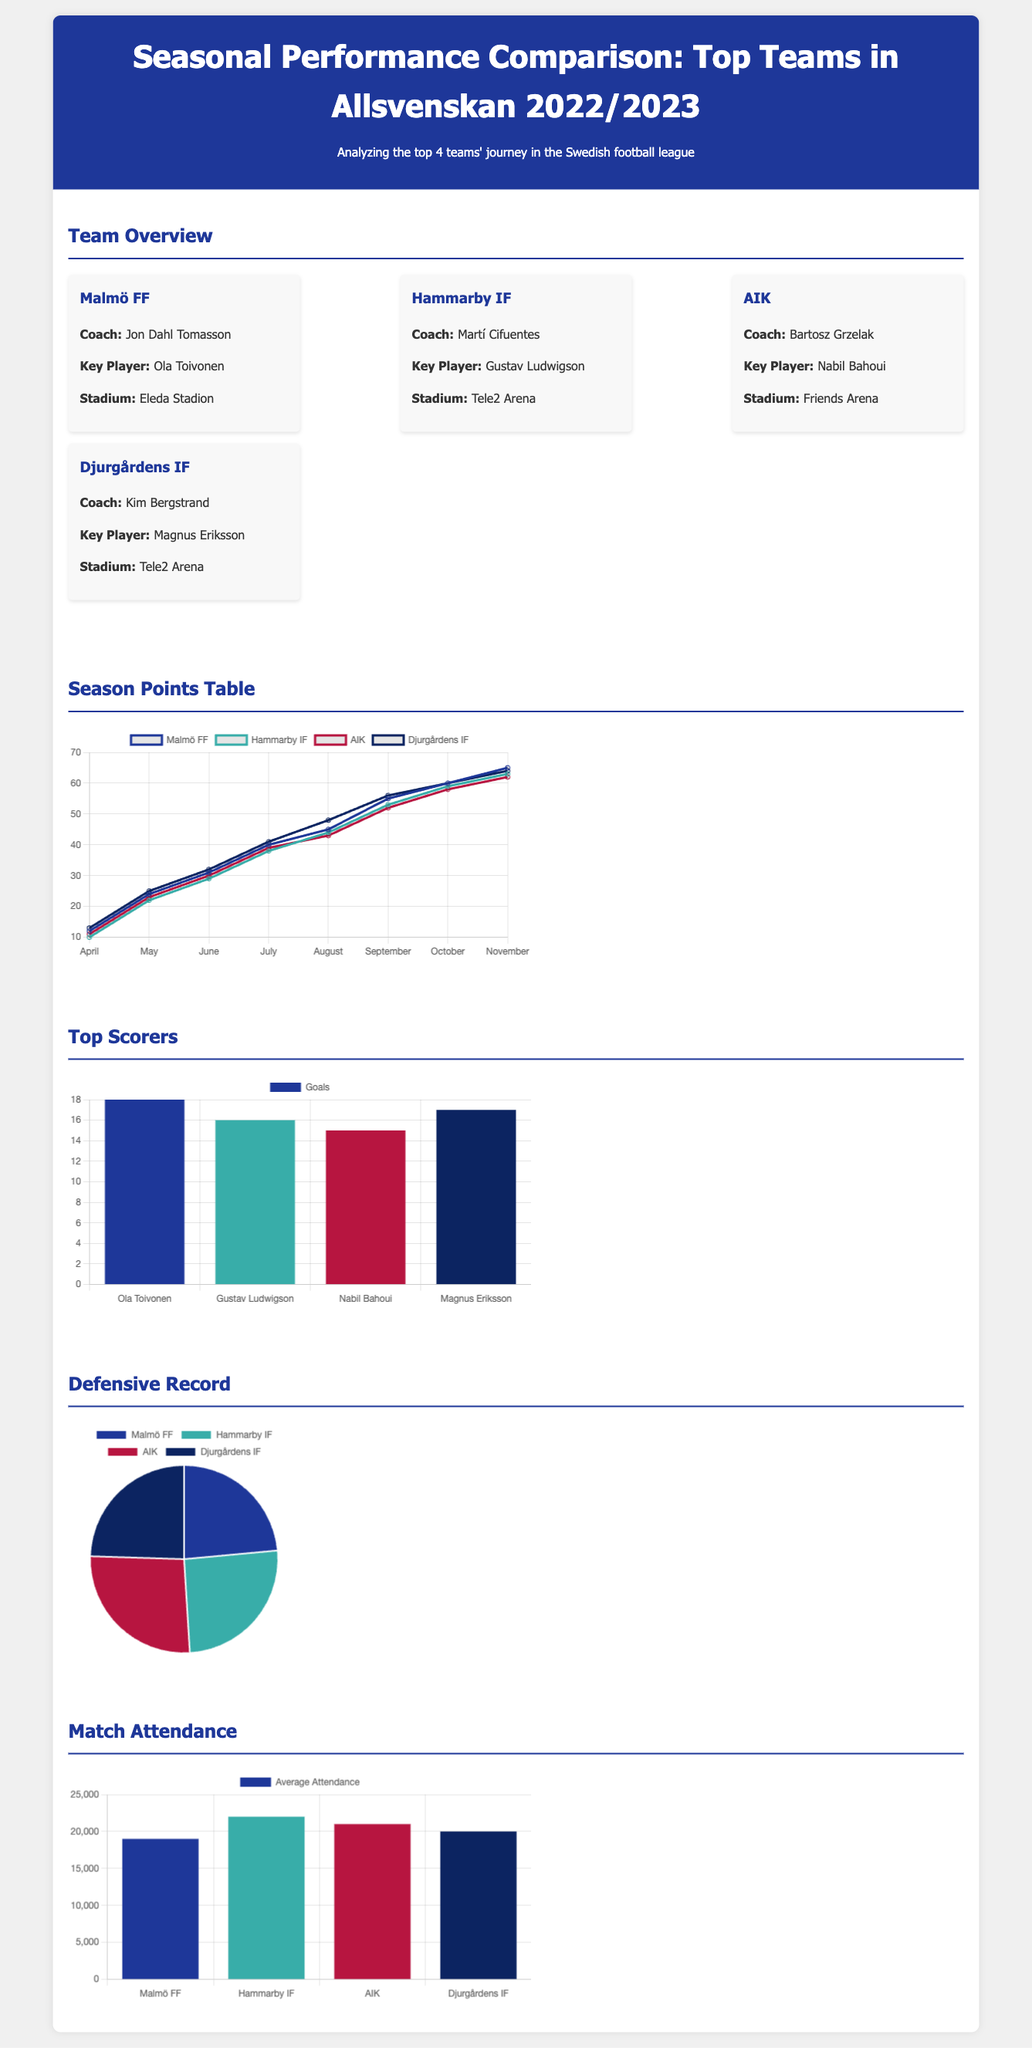What is the total number of goals scored by Ola Toivonen? Ola Toivonen scored 18 goals, as shown in the top scorers chart.
Answer: 18 Which team has the highest average match attendance? The average match attendance for Hammarby IF is the highest at 22,000, according to the attendance chart.
Answer: 22000 What is the defensive record of AIK in terms of goals conceded? AIK conceded 27 goals, which can be seen in the defensive record pie chart.
Answer: 27 What month did Malmö FF reach 40 points? Malmö FF reached 40 points in July, as indicated by the points table chart.
Answer: July Who is the key player for Djurgårdens IF? The key player for Djurgårdens IF is Magnus Eriksson, mentioned in the team overview section.
Answer: Magnus Eriksson Which coach leads Hammarby IF? Martí Cifuentes is the coach of Hammarby IF, as stated in the team overview.
Answer: Martí Cifuentes What was the total point score for Djurgårdens IF at the end of the season? Djurgårdens IF ended the season with 64 points, evidenced in the points progression chart.
Answer: 64 Which team has the lowest goals conceded? Malmö FF has the lowest goals conceded, with 24 goals, as shown in the defensive record chart.
Answer: Malmö FF 